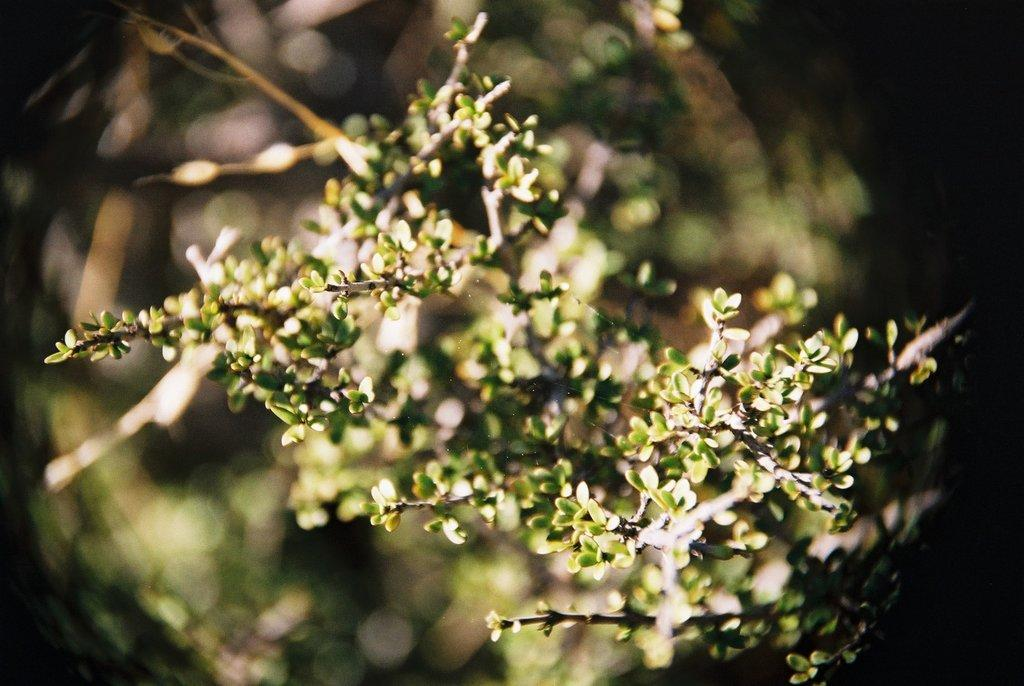What is present in the image? There is a plant in the image. Can you describe the background of the image? The background of the image is blurred. How many brothers are depicted in the image? There are no brothers present in the image, as it only features a plant and a blurred background. 